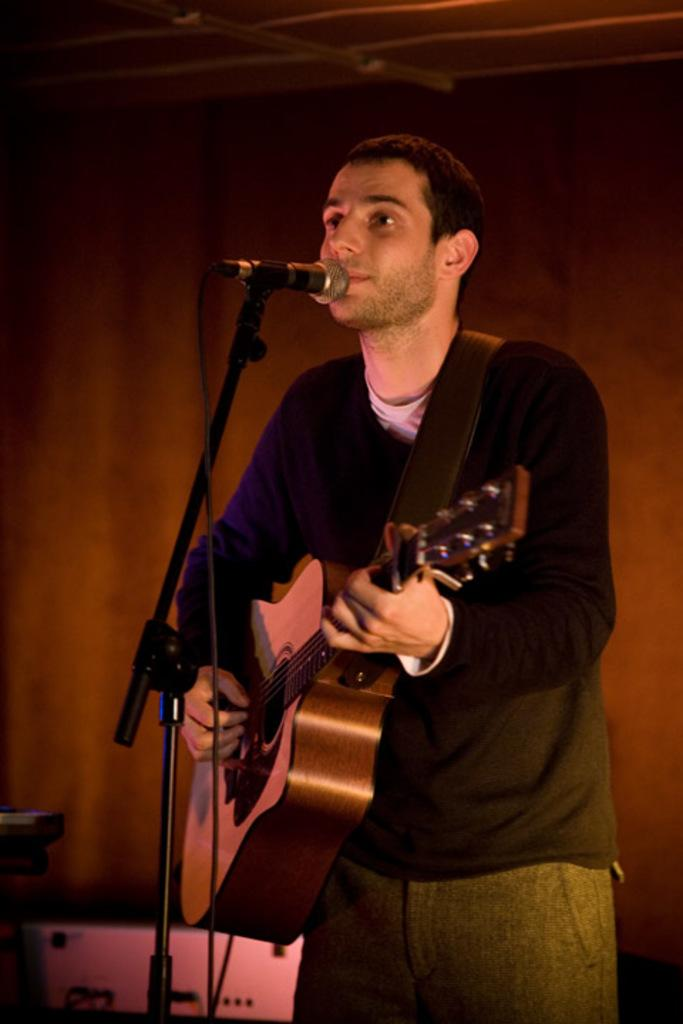Where was the image taken? The image was taken inside a room. What is the person in the image doing? The person is playing music on a guitar and singing with a microphone. What instrument is the person holding? The person is holding a guitar. What part of the room can be seen in the image? The roof is visible in the image. What color is the blade in the image? There is no blade present in the image. How much was the payment for the person's performance in the image? There is no information about payment in the image. 